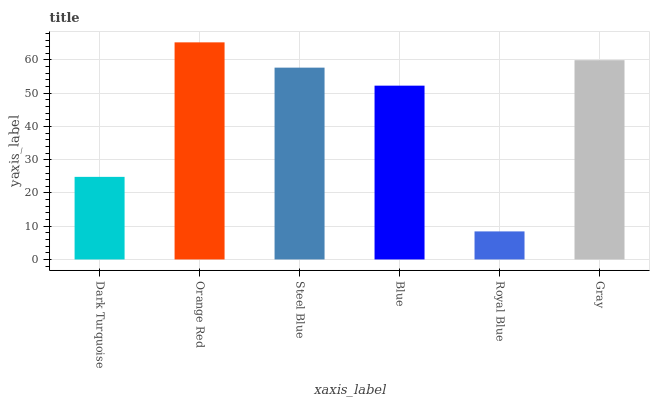Is Steel Blue the minimum?
Answer yes or no. No. Is Steel Blue the maximum?
Answer yes or no. No. Is Orange Red greater than Steel Blue?
Answer yes or no. Yes. Is Steel Blue less than Orange Red?
Answer yes or no. Yes. Is Steel Blue greater than Orange Red?
Answer yes or no. No. Is Orange Red less than Steel Blue?
Answer yes or no. No. Is Steel Blue the high median?
Answer yes or no. Yes. Is Blue the low median?
Answer yes or no. Yes. Is Gray the high median?
Answer yes or no. No. Is Gray the low median?
Answer yes or no. No. 